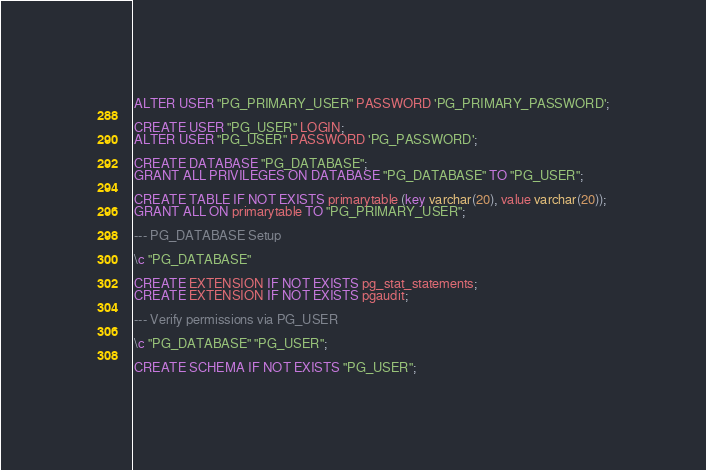Convert code to text. <code><loc_0><loc_0><loc_500><loc_500><_SQL_>ALTER USER "PG_PRIMARY_USER" PASSWORD 'PG_PRIMARY_PASSWORD';

CREATE USER "PG_USER" LOGIN;
ALTER USER "PG_USER" PASSWORD 'PG_PASSWORD';

CREATE DATABASE "PG_DATABASE";
GRANT ALL PRIVILEGES ON DATABASE "PG_DATABASE" TO "PG_USER";

CREATE TABLE IF NOT EXISTS primarytable (key varchar(20), value varchar(20));
GRANT ALL ON primarytable TO "PG_PRIMARY_USER";

--- PG_DATABASE Setup

\c "PG_DATABASE"

CREATE EXTENSION IF NOT EXISTS pg_stat_statements;
CREATE EXTENSION IF NOT EXISTS pgaudit;

--- Verify permissions via PG_USER

\c "PG_DATABASE" "PG_USER";

CREATE SCHEMA IF NOT EXISTS "PG_USER";
</code> 